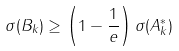<formula> <loc_0><loc_0><loc_500><loc_500>\sigma ( B _ { k } ) \geq \left ( 1 - \frac { 1 } { e } \right ) \sigma ( A ^ { * } _ { k } )</formula> 